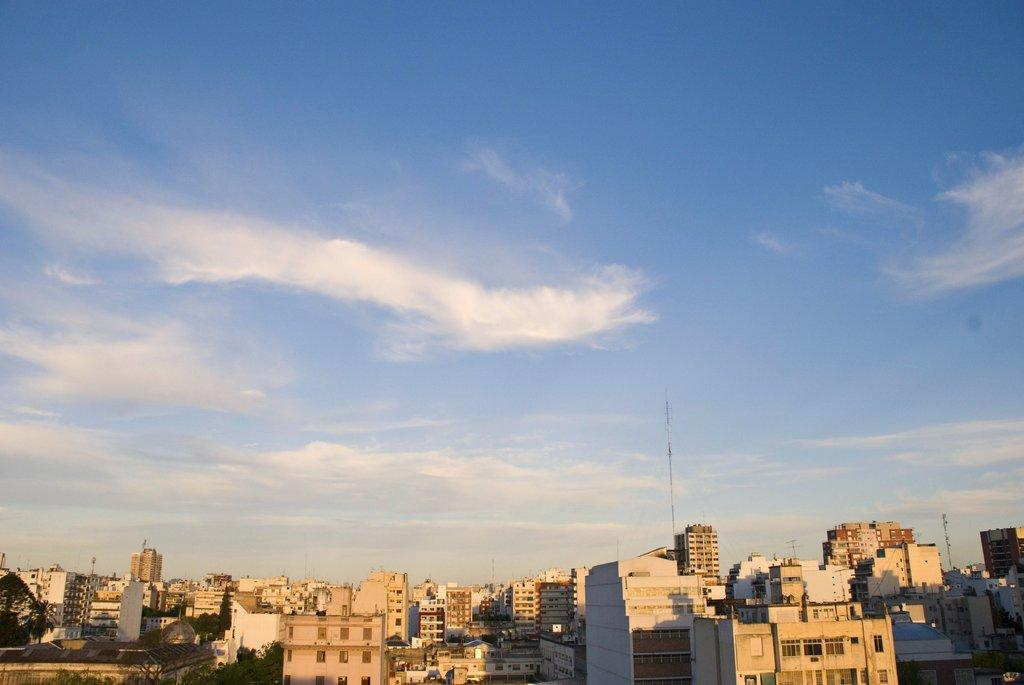What type of structures are visible in the image? There is a group of buildings in the image. Where are trees located in the image? Trees are present in the bottom left of the image. What can be seen in the sky in the image? The sky is visible at the top of the image and is clear. Can you tell me how many experts are standing inside the cave in the image? There is no cave or expert present in the image. What is the color of the mouth of the person in the image? There is no person or mouth present in the image. 